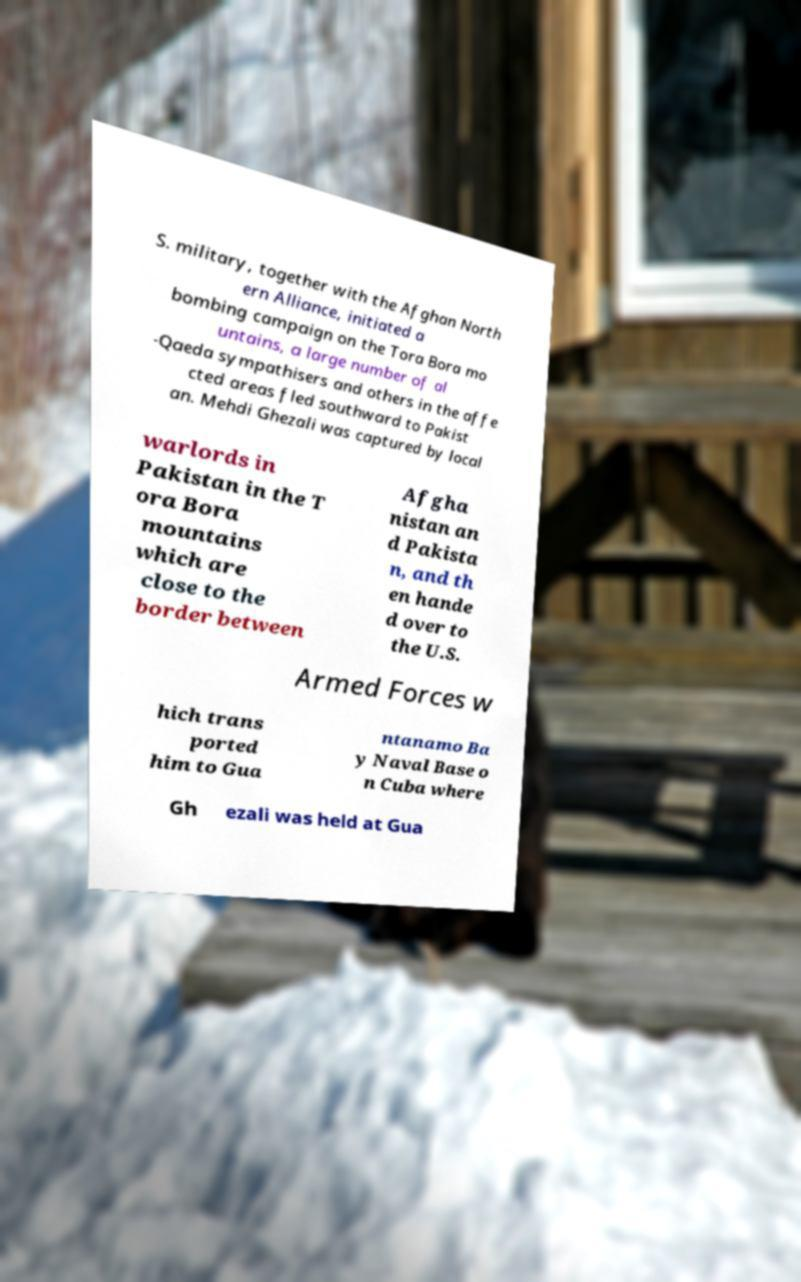Could you assist in decoding the text presented in this image and type it out clearly? S. military, together with the Afghan North ern Alliance, initiated a bombing campaign on the Tora Bora mo untains, a large number of al -Qaeda sympathisers and others in the affe cted areas fled southward to Pakist an. Mehdi Ghezali was captured by local warlords in Pakistan in the T ora Bora mountains which are close to the border between Afgha nistan an d Pakista n, and th en hande d over to the U.S. Armed Forces w hich trans ported him to Gua ntanamo Ba y Naval Base o n Cuba where Gh ezali was held at Gua 